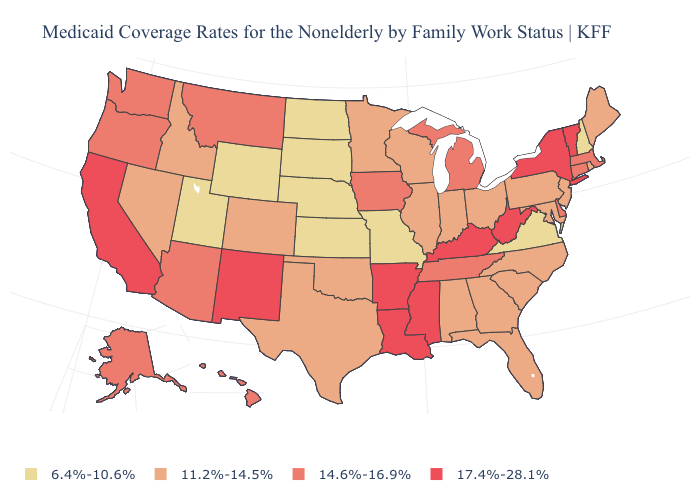Name the states that have a value in the range 14.6%-16.9%?
Short answer required. Alaska, Arizona, Connecticut, Delaware, Hawaii, Iowa, Massachusetts, Michigan, Montana, Oregon, Tennessee, Washington. What is the highest value in the MidWest ?
Concise answer only. 14.6%-16.9%. Is the legend a continuous bar?
Keep it brief. No. Which states have the highest value in the USA?
Be succinct. Arkansas, California, Kentucky, Louisiana, Mississippi, New Mexico, New York, Vermont, West Virginia. What is the value of Illinois?
Answer briefly. 11.2%-14.5%. Does the first symbol in the legend represent the smallest category?
Be succinct. Yes. How many symbols are there in the legend?
Write a very short answer. 4. What is the lowest value in states that border North Carolina?
Quick response, please. 6.4%-10.6%. Name the states that have a value in the range 14.6%-16.9%?
Write a very short answer. Alaska, Arizona, Connecticut, Delaware, Hawaii, Iowa, Massachusetts, Michigan, Montana, Oregon, Tennessee, Washington. Among the states that border New York , which have the highest value?
Give a very brief answer. Vermont. Name the states that have a value in the range 11.2%-14.5%?
Give a very brief answer. Alabama, Colorado, Florida, Georgia, Idaho, Illinois, Indiana, Maine, Maryland, Minnesota, Nevada, New Jersey, North Carolina, Ohio, Oklahoma, Pennsylvania, Rhode Island, South Carolina, Texas, Wisconsin. How many symbols are there in the legend?
Keep it brief. 4. Name the states that have a value in the range 6.4%-10.6%?
Quick response, please. Kansas, Missouri, Nebraska, New Hampshire, North Dakota, South Dakota, Utah, Virginia, Wyoming. Name the states that have a value in the range 11.2%-14.5%?
Give a very brief answer. Alabama, Colorado, Florida, Georgia, Idaho, Illinois, Indiana, Maine, Maryland, Minnesota, Nevada, New Jersey, North Carolina, Ohio, Oklahoma, Pennsylvania, Rhode Island, South Carolina, Texas, Wisconsin. 